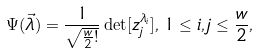Convert formula to latex. <formula><loc_0><loc_0><loc_500><loc_500>\Psi ( \vec { \lambda } ) = \frac { 1 } { \sqrt { \frac { w } { 2 } ! } } \det [ z _ { j } ^ { \lambda _ { i } } ] , \, 1 \leq i , j \leq \frac { w } { 2 } ,</formula> 